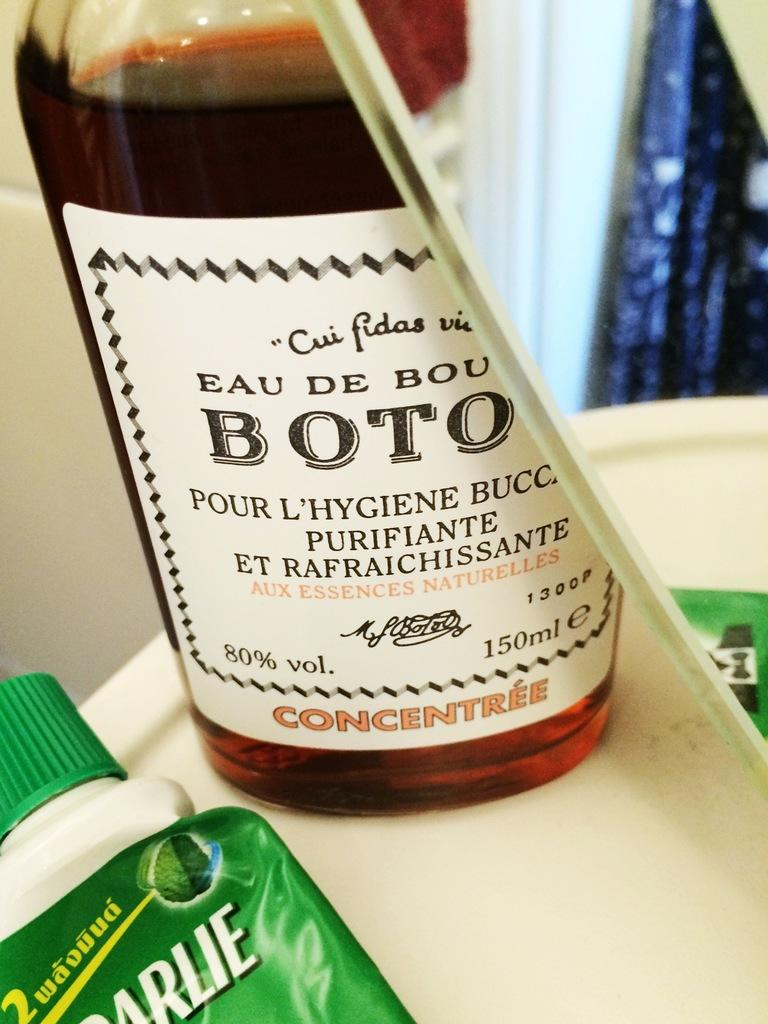<image>
Relay a brief, clear account of the picture shown. A bottle with brown liquid in it that is a concentree. 